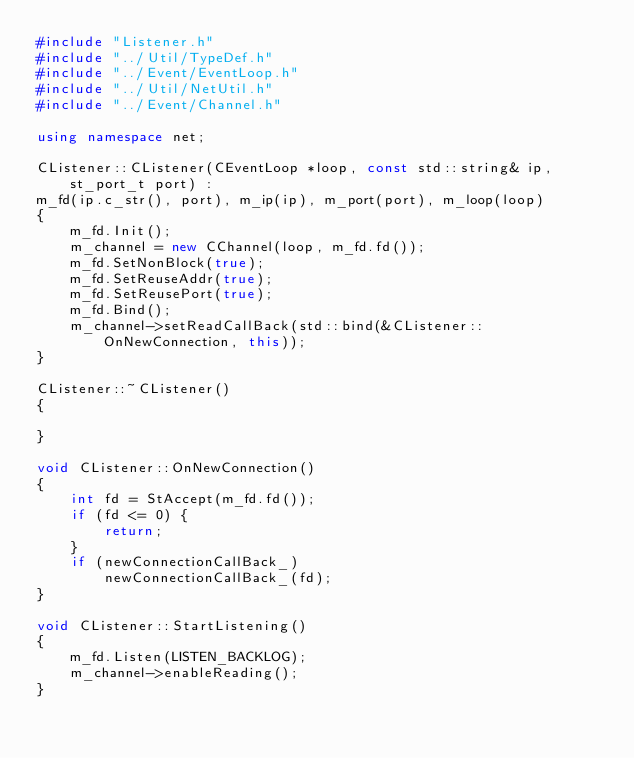Convert code to text. <code><loc_0><loc_0><loc_500><loc_500><_C++_>#include "Listener.h"
#include "../Util/TypeDef.h"
#include "../Event/EventLoop.h"
#include "../Util/NetUtil.h"
#include "../Event/Channel.h"

using namespace net;

CListener::CListener(CEventLoop *loop, const std::string& ip, st_port_t port) : 
m_fd(ip.c_str(), port), m_ip(ip), m_port(port), m_loop(loop)
{
	m_fd.Init();
	m_channel = new CChannel(loop, m_fd.fd());
	m_fd.SetNonBlock(true);
	m_fd.SetReuseAddr(true);
	m_fd.SetReusePort(true);
	m_fd.Bind();
	m_channel->setReadCallBack(std::bind(&CListener::OnNewConnection, this));
}

CListener::~CListener()
{

}

void CListener::OnNewConnection()
{
	int fd = StAccept(m_fd.fd());
	if (fd <= 0) {
		return;
	}
	if (newConnectionCallBack_)
		newConnectionCallBack_(fd);
}

void CListener::StartListening()
{
	m_fd.Listen(LISTEN_BACKLOG);
	m_channel->enableReading();
}</code> 